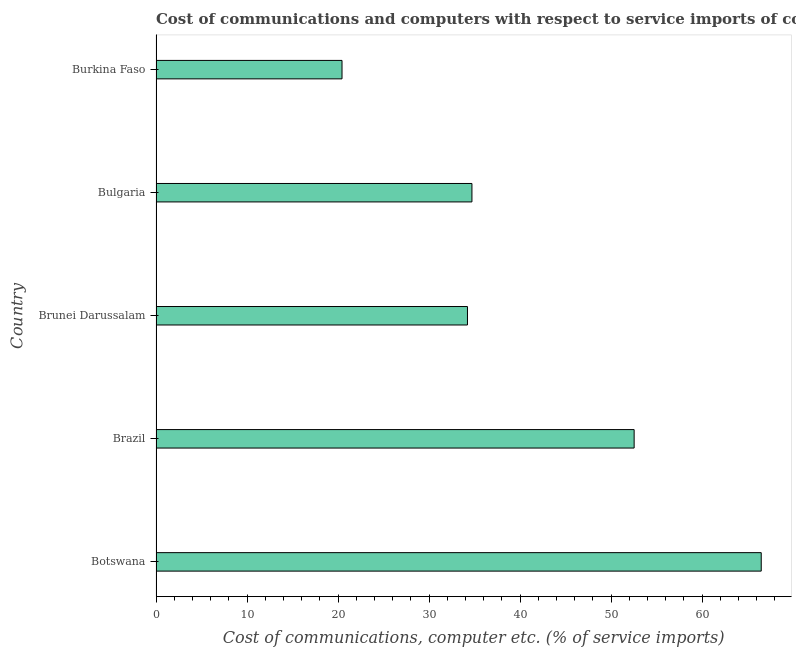Does the graph contain any zero values?
Your answer should be compact. No. What is the title of the graph?
Provide a succinct answer. Cost of communications and computers with respect to service imports of countries in 2009. What is the label or title of the X-axis?
Make the answer very short. Cost of communications, computer etc. (% of service imports). What is the label or title of the Y-axis?
Your answer should be compact. Country. What is the cost of communications and computer in Brazil?
Your answer should be very brief. 52.54. Across all countries, what is the maximum cost of communications and computer?
Keep it short and to the point. 66.51. Across all countries, what is the minimum cost of communications and computer?
Your answer should be compact. 20.44. In which country was the cost of communications and computer maximum?
Make the answer very short. Botswana. In which country was the cost of communications and computer minimum?
Make the answer very short. Burkina Faso. What is the sum of the cost of communications and computer?
Offer a very short reply. 208.43. What is the difference between the cost of communications and computer in Bulgaria and Burkina Faso?
Your answer should be very brief. 14.28. What is the average cost of communications and computer per country?
Provide a succinct answer. 41.69. What is the median cost of communications and computer?
Your answer should be very brief. 34.72. What is the ratio of the cost of communications and computer in Brunei Darussalam to that in Burkina Faso?
Your answer should be compact. 1.67. What is the difference between the highest and the second highest cost of communications and computer?
Provide a short and direct response. 13.97. Is the sum of the cost of communications and computer in Botswana and Burkina Faso greater than the maximum cost of communications and computer across all countries?
Make the answer very short. Yes. What is the difference between the highest and the lowest cost of communications and computer?
Provide a succinct answer. 46.07. How many bars are there?
Your response must be concise. 5. Are all the bars in the graph horizontal?
Offer a terse response. Yes. How many countries are there in the graph?
Your answer should be very brief. 5. What is the difference between two consecutive major ticks on the X-axis?
Make the answer very short. 10. Are the values on the major ticks of X-axis written in scientific E-notation?
Ensure brevity in your answer.  No. What is the Cost of communications, computer etc. (% of service imports) in Botswana?
Give a very brief answer. 66.51. What is the Cost of communications, computer etc. (% of service imports) of Brazil?
Your response must be concise. 52.54. What is the Cost of communications, computer etc. (% of service imports) of Brunei Darussalam?
Your answer should be very brief. 34.22. What is the Cost of communications, computer etc. (% of service imports) in Bulgaria?
Your answer should be compact. 34.72. What is the Cost of communications, computer etc. (% of service imports) in Burkina Faso?
Offer a very short reply. 20.44. What is the difference between the Cost of communications, computer etc. (% of service imports) in Botswana and Brazil?
Make the answer very short. 13.97. What is the difference between the Cost of communications, computer etc. (% of service imports) in Botswana and Brunei Darussalam?
Keep it short and to the point. 32.28. What is the difference between the Cost of communications, computer etc. (% of service imports) in Botswana and Bulgaria?
Your answer should be very brief. 31.79. What is the difference between the Cost of communications, computer etc. (% of service imports) in Botswana and Burkina Faso?
Your answer should be very brief. 46.07. What is the difference between the Cost of communications, computer etc. (% of service imports) in Brazil and Brunei Darussalam?
Provide a short and direct response. 18.32. What is the difference between the Cost of communications, computer etc. (% of service imports) in Brazil and Bulgaria?
Give a very brief answer. 17.83. What is the difference between the Cost of communications, computer etc. (% of service imports) in Brazil and Burkina Faso?
Keep it short and to the point. 32.1. What is the difference between the Cost of communications, computer etc. (% of service imports) in Brunei Darussalam and Bulgaria?
Provide a short and direct response. -0.49. What is the difference between the Cost of communications, computer etc. (% of service imports) in Brunei Darussalam and Burkina Faso?
Your response must be concise. 13.79. What is the difference between the Cost of communications, computer etc. (% of service imports) in Bulgaria and Burkina Faso?
Keep it short and to the point. 14.28. What is the ratio of the Cost of communications, computer etc. (% of service imports) in Botswana to that in Brazil?
Your response must be concise. 1.27. What is the ratio of the Cost of communications, computer etc. (% of service imports) in Botswana to that in Brunei Darussalam?
Your answer should be very brief. 1.94. What is the ratio of the Cost of communications, computer etc. (% of service imports) in Botswana to that in Bulgaria?
Your answer should be very brief. 1.92. What is the ratio of the Cost of communications, computer etc. (% of service imports) in Botswana to that in Burkina Faso?
Your answer should be very brief. 3.25. What is the ratio of the Cost of communications, computer etc. (% of service imports) in Brazil to that in Brunei Darussalam?
Give a very brief answer. 1.53. What is the ratio of the Cost of communications, computer etc. (% of service imports) in Brazil to that in Bulgaria?
Your answer should be compact. 1.51. What is the ratio of the Cost of communications, computer etc. (% of service imports) in Brazil to that in Burkina Faso?
Your answer should be very brief. 2.57. What is the ratio of the Cost of communications, computer etc. (% of service imports) in Brunei Darussalam to that in Burkina Faso?
Make the answer very short. 1.67. What is the ratio of the Cost of communications, computer etc. (% of service imports) in Bulgaria to that in Burkina Faso?
Provide a succinct answer. 1.7. 